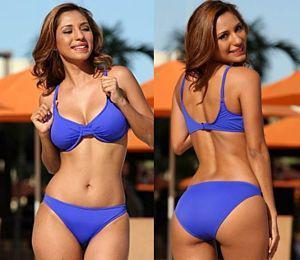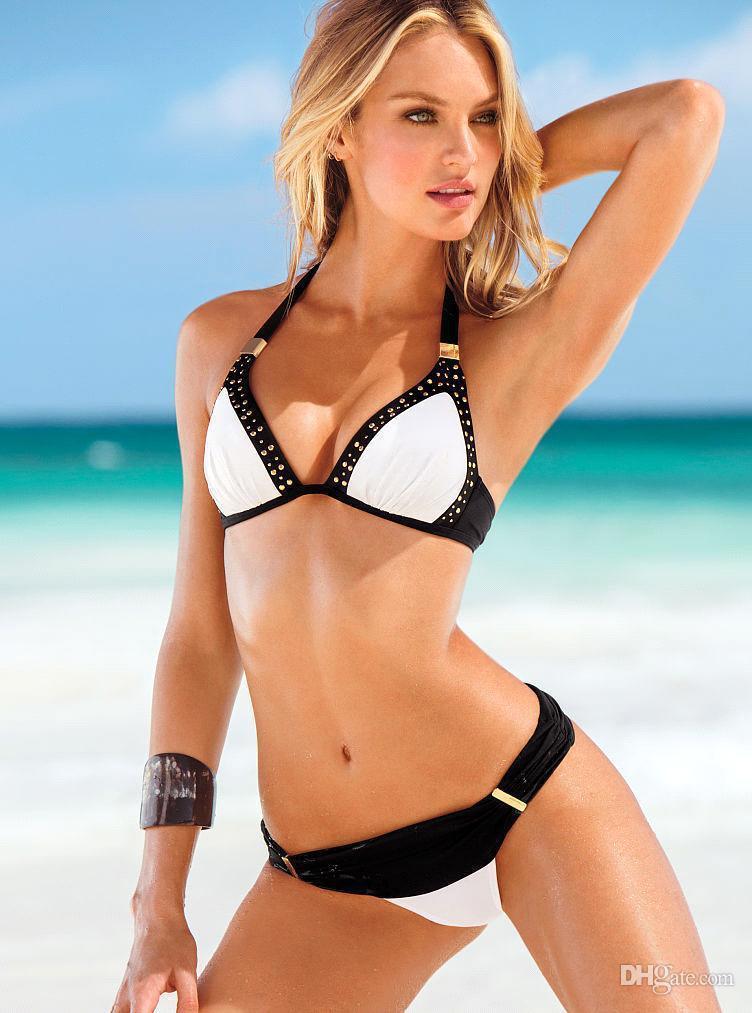The first image is the image on the left, the second image is the image on the right. For the images shown, is this caption "An image shows three models in different bikini colors." true? Answer yes or no. No. The first image is the image on the left, the second image is the image on the right. Given the left and right images, does the statement "There is at least two females in a bikini in the right image." hold true? Answer yes or no. No. 